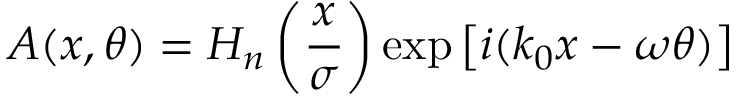<formula> <loc_0><loc_0><loc_500><loc_500>A ( x , \theta ) = H _ { n } \left ( \frac { x } { \sigma } \right ) \exp \left [ i ( k _ { 0 } x - \omega \theta ) \right ]</formula> 